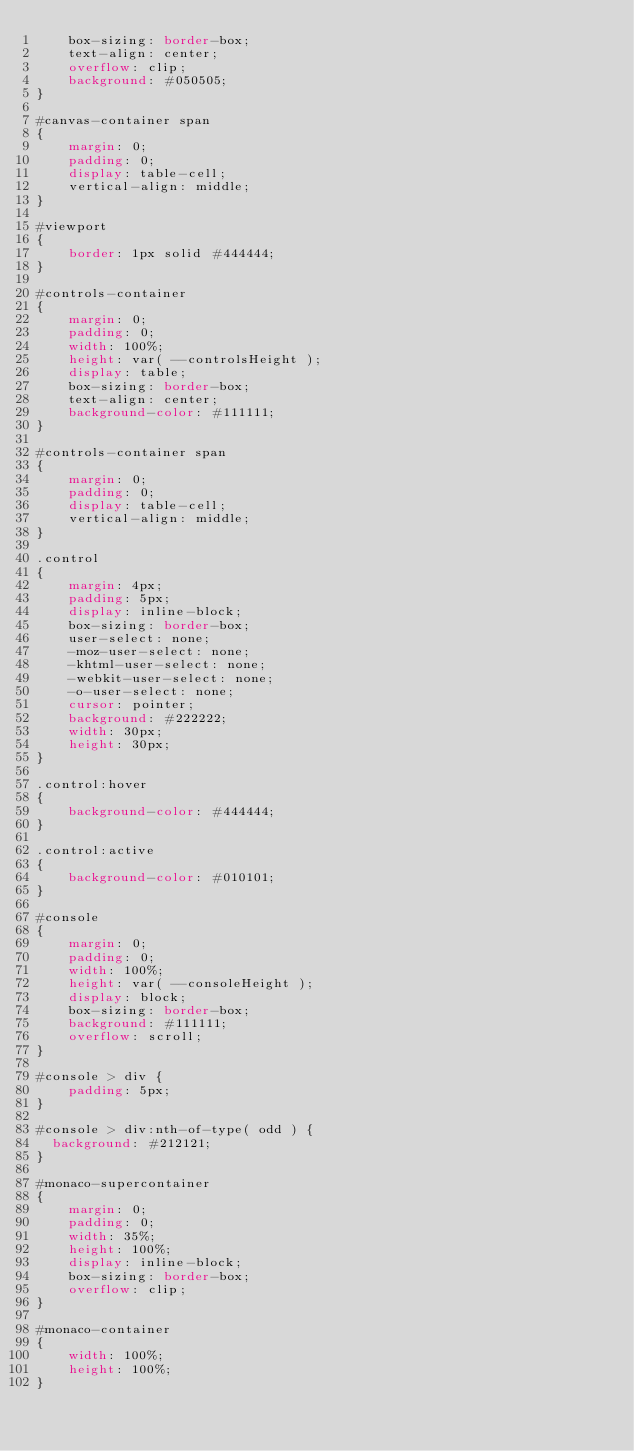Convert code to text. <code><loc_0><loc_0><loc_500><loc_500><_CSS_>    box-sizing: border-box;
    text-align: center;
    overflow: clip;
    background: #050505;
}

#canvas-container span
{
    margin: 0;
    padding: 0;
    display: table-cell;
    vertical-align: middle;
}

#viewport
{
    border: 1px solid #444444;
}

#controls-container
{
    margin: 0;
    padding: 0;
    width: 100%;
    height: var( --controlsHeight );
    display: table;
    box-sizing: border-box;
    text-align: center;
    background-color: #111111;
}

#controls-container span
{
    margin: 0;
    padding: 0;
    display: table-cell;
    vertical-align: middle;
}

.control
{
    margin: 4px;
    padding: 5px;
    display: inline-block;
    box-sizing: border-box;
    user-select: none;
    -moz-user-select: none;
    -khtml-user-select: none;
    -webkit-user-select: none;
    -o-user-select: none;
    cursor: pointer;
    background: #222222;
    width: 30px;
    height: 30px;
}

.control:hover
{
    background-color: #444444;
}

.control:active
{
    background-color: #010101;
}

#console
{
    margin: 0;
    padding: 0;
    width: 100%;
    height: var( --consoleHeight );
    display: block;
    box-sizing: border-box;
    background: #111111;
    overflow: scroll;
}

#console > div {
    padding: 5px;
}

#console > div:nth-of-type( odd ) {
  background: #212121;
}

#monaco-supercontainer
{
    margin: 0;
    padding: 0;
    width: 35%;
    height: 100%;
    display: inline-block;
    box-sizing: border-box;
    overflow: clip;
}

#monaco-container
{
    width: 100%;
    height: 100%;
}

</code> 